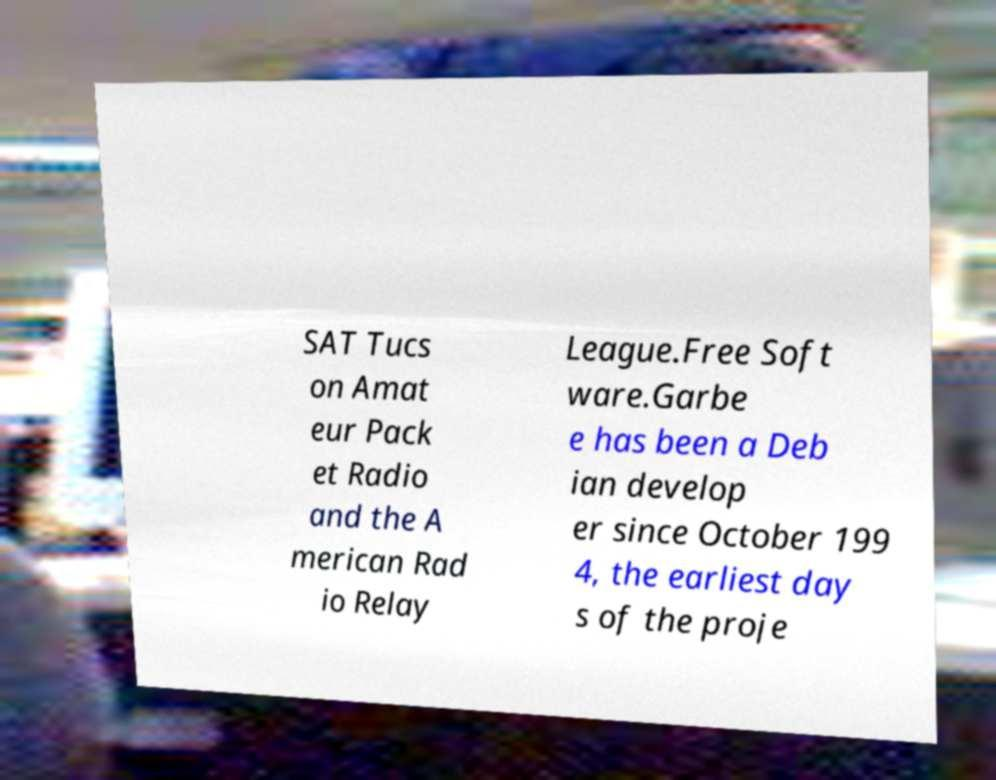What messages or text are displayed in this image? I need them in a readable, typed format. SAT Tucs on Amat eur Pack et Radio and the A merican Rad io Relay League.Free Soft ware.Garbe e has been a Deb ian develop er since October 199 4, the earliest day s of the proje 